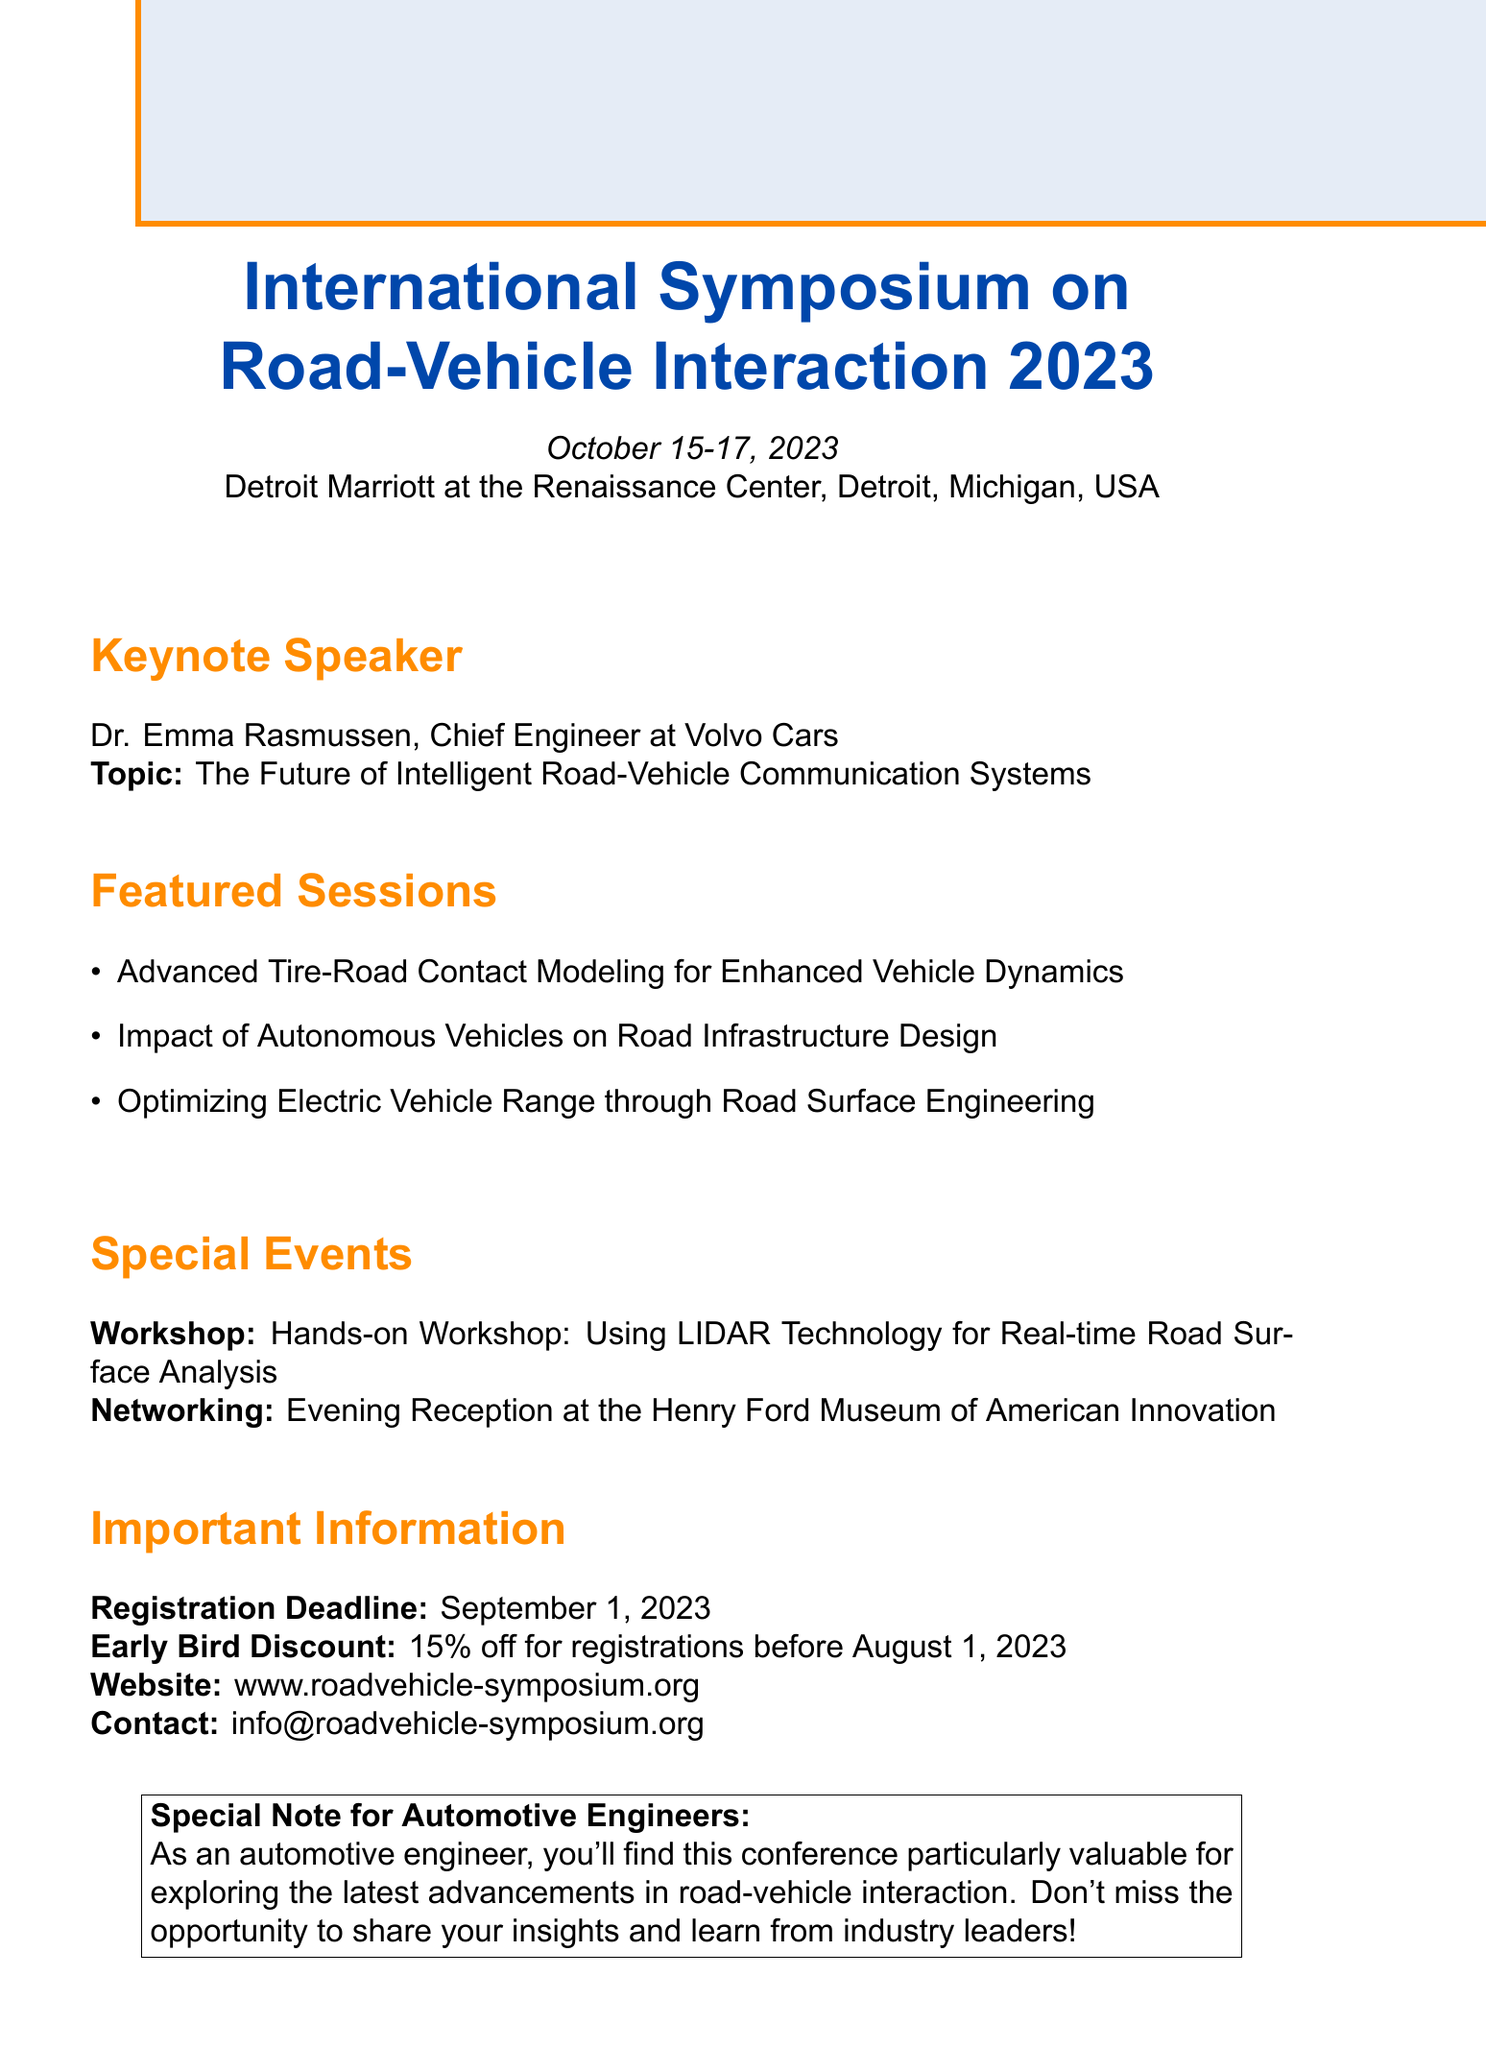What are the dates of the conference? The dates for the conference are provided in the document.
Answer: October 15-17, 2023 Who is the keynote speaker? The document specifies the name and role of the keynote speaker.
Answer: Dr. Emma Rasmussen What is the theme of the keynote speech? The document includes the topic of the keynote speech delivered by Dr. Emma Rasmussen.
Answer: The Future of Intelligent Road-Vehicle Communication Systems What is one topic covered in the featured sessions? The document lists several featured session topics, allowing for retrieval of any of them.
Answer: Advanced Tire-Road Contact Modeling for Enhanced Vehicle Dynamics What is the registration deadline? The document states the final date for registration explicitly.
Answer: September 1, 2023 What is the early bird discount percentage? The document mentions the percentage discount for early registrations.
Answer: 15% What workshop is offered during the conference? The document describes a hands-on workshop available at the conference.
Answer: Hands-on Workshop: Using LIDAR Technology for Real-time Road Surface Analysis What is the venue for the conference? The document specifies the location where the conference is held.
Answer: Detroit Marriott at the Renaissance Center, Detroit, Michigan, USA Where can additional information be found online? The document includes a website link for further details about the conference.
Answer: www.roadvehicle-symposium.org What special note is directed towards automotive engineers? The document contains a specific note of value for automotive engineers.
Answer: As an automotive engineer, you'll find this conference particularly valuable for exploring the latest advancements in road-vehicle interaction 